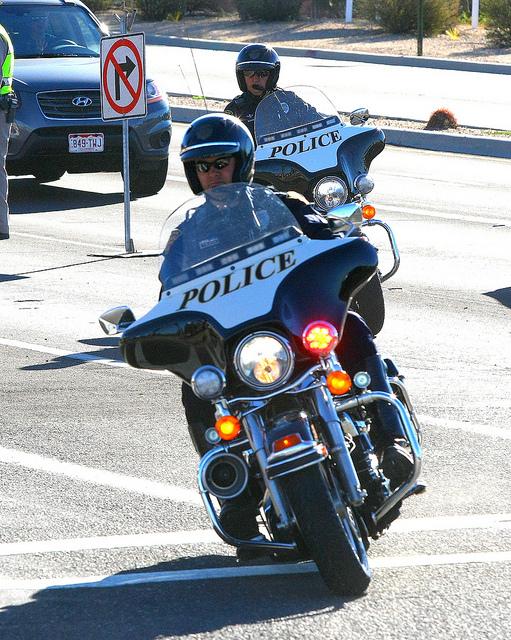What is the 3-digit phone number for these guys in America?
Write a very short answer. 911. What make is the car behind the policemen?
Be succinct. Hyundai. What are the two men riding on?
Give a very brief answer. Motorcycles. 